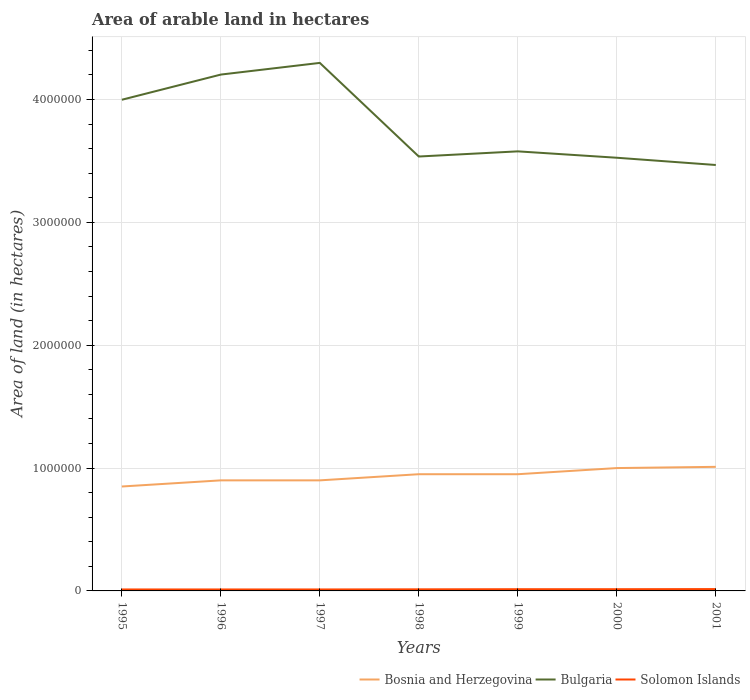Does the line corresponding to Bulgaria intersect with the line corresponding to Solomon Islands?
Your response must be concise. No. Across all years, what is the maximum total arable land in Bosnia and Herzegovina?
Make the answer very short. 8.50e+05. What is the total total arable land in Bosnia and Herzegovina in the graph?
Provide a short and direct response. -1.10e+05. What is the difference between the highest and the second highest total arable land in Solomon Islands?
Make the answer very short. 3000. What is the difference between the highest and the lowest total arable land in Bosnia and Herzegovina?
Your answer should be compact. 4. What is the difference between two consecutive major ticks on the Y-axis?
Offer a terse response. 1.00e+06. Where does the legend appear in the graph?
Give a very brief answer. Bottom right. How many legend labels are there?
Your answer should be very brief. 3. How are the legend labels stacked?
Provide a succinct answer. Horizontal. What is the title of the graph?
Provide a short and direct response. Area of arable land in hectares. Does "Arab World" appear as one of the legend labels in the graph?
Give a very brief answer. No. What is the label or title of the X-axis?
Make the answer very short. Years. What is the label or title of the Y-axis?
Your answer should be very brief. Area of land (in hectares). What is the Area of land (in hectares) in Bosnia and Herzegovina in 1995?
Your answer should be very brief. 8.50e+05. What is the Area of land (in hectares) in Bulgaria in 1995?
Offer a very short reply. 4.00e+06. What is the Area of land (in hectares) of Solomon Islands in 1995?
Offer a very short reply. 1.20e+04. What is the Area of land (in hectares) of Bosnia and Herzegovina in 1996?
Give a very brief answer. 9.00e+05. What is the Area of land (in hectares) of Bulgaria in 1996?
Make the answer very short. 4.20e+06. What is the Area of land (in hectares) in Solomon Islands in 1996?
Your answer should be compact. 1.20e+04. What is the Area of land (in hectares) of Bulgaria in 1997?
Ensure brevity in your answer.  4.30e+06. What is the Area of land (in hectares) in Solomon Islands in 1997?
Give a very brief answer. 1.20e+04. What is the Area of land (in hectares) of Bosnia and Herzegovina in 1998?
Your response must be concise. 9.50e+05. What is the Area of land (in hectares) of Bulgaria in 1998?
Your response must be concise. 3.54e+06. What is the Area of land (in hectares) of Solomon Islands in 1998?
Provide a short and direct response. 1.30e+04. What is the Area of land (in hectares) in Bosnia and Herzegovina in 1999?
Keep it short and to the point. 9.50e+05. What is the Area of land (in hectares) of Bulgaria in 1999?
Provide a short and direct response. 3.58e+06. What is the Area of land (in hectares) in Solomon Islands in 1999?
Keep it short and to the point. 1.40e+04. What is the Area of land (in hectares) in Bosnia and Herzegovina in 2000?
Provide a succinct answer. 1.00e+06. What is the Area of land (in hectares) of Bulgaria in 2000?
Offer a very short reply. 3.53e+06. What is the Area of land (in hectares) of Solomon Islands in 2000?
Make the answer very short. 1.40e+04. What is the Area of land (in hectares) in Bosnia and Herzegovina in 2001?
Your response must be concise. 1.01e+06. What is the Area of land (in hectares) in Bulgaria in 2001?
Offer a terse response. 3.47e+06. What is the Area of land (in hectares) of Solomon Islands in 2001?
Offer a terse response. 1.50e+04. Across all years, what is the maximum Area of land (in hectares) of Bosnia and Herzegovina?
Ensure brevity in your answer.  1.01e+06. Across all years, what is the maximum Area of land (in hectares) of Bulgaria?
Make the answer very short. 4.30e+06. Across all years, what is the maximum Area of land (in hectares) in Solomon Islands?
Provide a short and direct response. 1.50e+04. Across all years, what is the minimum Area of land (in hectares) in Bosnia and Herzegovina?
Keep it short and to the point. 8.50e+05. Across all years, what is the minimum Area of land (in hectares) of Bulgaria?
Offer a terse response. 3.47e+06. Across all years, what is the minimum Area of land (in hectares) of Solomon Islands?
Your answer should be compact. 1.20e+04. What is the total Area of land (in hectares) in Bosnia and Herzegovina in the graph?
Give a very brief answer. 6.56e+06. What is the total Area of land (in hectares) of Bulgaria in the graph?
Give a very brief answer. 2.66e+07. What is the total Area of land (in hectares) of Solomon Islands in the graph?
Ensure brevity in your answer.  9.20e+04. What is the difference between the Area of land (in hectares) in Bulgaria in 1995 and that in 1996?
Ensure brevity in your answer.  -2.05e+05. What is the difference between the Area of land (in hectares) in Bosnia and Herzegovina in 1995 and that in 1997?
Your response must be concise. -5.00e+04. What is the difference between the Area of land (in hectares) of Bulgaria in 1995 and that in 1997?
Your answer should be compact. -3.00e+05. What is the difference between the Area of land (in hectares) in Solomon Islands in 1995 and that in 1997?
Your response must be concise. 0. What is the difference between the Area of land (in hectares) of Bulgaria in 1995 and that in 1998?
Offer a terse response. 4.62e+05. What is the difference between the Area of land (in hectares) of Solomon Islands in 1995 and that in 1998?
Make the answer very short. -1000. What is the difference between the Area of land (in hectares) in Bulgaria in 1995 and that in 1999?
Offer a terse response. 4.20e+05. What is the difference between the Area of land (in hectares) of Solomon Islands in 1995 and that in 1999?
Make the answer very short. -2000. What is the difference between the Area of land (in hectares) in Bosnia and Herzegovina in 1995 and that in 2000?
Your answer should be compact. -1.50e+05. What is the difference between the Area of land (in hectares) of Bulgaria in 1995 and that in 2000?
Provide a succinct answer. 4.72e+05. What is the difference between the Area of land (in hectares) in Solomon Islands in 1995 and that in 2000?
Keep it short and to the point. -2000. What is the difference between the Area of land (in hectares) of Bosnia and Herzegovina in 1995 and that in 2001?
Your answer should be very brief. -1.60e+05. What is the difference between the Area of land (in hectares) of Bulgaria in 1995 and that in 2001?
Ensure brevity in your answer.  5.31e+05. What is the difference between the Area of land (in hectares) in Solomon Islands in 1995 and that in 2001?
Provide a succinct answer. -3000. What is the difference between the Area of land (in hectares) in Bosnia and Herzegovina in 1996 and that in 1997?
Offer a terse response. 0. What is the difference between the Area of land (in hectares) in Bulgaria in 1996 and that in 1997?
Ensure brevity in your answer.  -9.50e+04. What is the difference between the Area of land (in hectares) in Bosnia and Herzegovina in 1996 and that in 1998?
Ensure brevity in your answer.  -5.00e+04. What is the difference between the Area of land (in hectares) of Bulgaria in 1996 and that in 1998?
Keep it short and to the point. 6.67e+05. What is the difference between the Area of land (in hectares) of Solomon Islands in 1996 and that in 1998?
Keep it short and to the point. -1000. What is the difference between the Area of land (in hectares) of Bosnia and Herzegovina in 1996 and that in 1999?
Ensure brevity in your answer.  -5.00e+04. What is the difference between the Area of land (in hectares) in Bulgaria in 1996 and that in 1999?
Provide a short and direct response. 6.25e+05. What is the difference between the Area of land (in hectares) of Solomon Islands in 1996 and that in 1999?
Make the answer very short. -2000. What is the difference between the Area of land (in hectares) of Bosnia and Herzegovina in 1996 and that in 2000?
Keep it short and to the point. -1.00e+05. What is the difference between the Area of land (in hectares) of Bulgaria in 1996 and that in 2000?
Your response must be concise. 6.77e+05. What is the difference between the Area of land (in hectares) of Solomon Islands in 1996 and that in 2000?
Offer a terse response. -2000. What is the difference between the Area of land (in hectares) of Bosnia and Herzegovina in 1996 and that in 2001?
Provide a short and direct response. -1.10e+05. What is the difference between the Area of land (in hectares) of Bulgaria in 1996 and that in 2001?
Keep it short and to the point. 7.36e+05. What is the difference between the Area of land (in hectares) in Solomon Islands in 1996 and that in 2001?
Provide a short and direct response. -3000. What is the difference between the Area of land (in hectares) in Bosnia and Herzegovina in 1997 and that in 1998?
Give a very brief answer. -5.00e+04. What is the difference between the Area of land (in hectares) in Bulgaria in 1997 and that in 1998?
Offer a terse response. 7.62e+05. What is the difference between the Area of land (in hectares) in Solomon Islands in 1997 and that in 1998?
Your response must be concise. -1000. What is the difference between the Area of land (in hectares) in Bulgaria in 1997 and that in 1999?
Ensure brevity in your answer.  7.20e+05. What is the difference between the Area of land (in hectares) in Solomon Islands in 1997 and that in 1999?
Give a very brief answer. -2000. What is the difference between the Area of land (in hectares) in Bulgaria in 1997 and that in 2000?
Provide a short and direct response. 7.72e+05. What is the difference between the Area of land (in hectares) in Solomon Islands in 1997 and that in 2000?
Your answer should be compact. -2000. What is the difference between the Area of land (in hectares) of Bosnia and Herzegovina in 1997 and that in 2001?
Your answer should be very brief. -1.10e+05. What is the difference between the Area of land (in hectares) in Bulgaria in 1997 and that in 2001?
Make the answer very short. 8.31e+05. What is the difference between the Area of land (in hectares) of Solomon Islands in 1997 and that in 2001?
Ensure brevity in your answer.  -3000. What is the difference between the Area of land (in hectares) of Bulgaria in 1998 and that in 1999?
Make the answer very short. -4.20e+04. What is the difference between the Area of land (in hectares) in Solomon Islands in 1998 and that in 1999?
Make the answer very short. -1000. What is the difference between the Area of land (in hectares) of Bosnia and Herzegovina in 1998 and that in 2000?
Ensure brevity in your answer.  -5.00e+04. What is the difference between the Area of land (in hectares) of Bulgaria in 1998 and that in 2000?
Your answer should be very brief. 10000. What is the difference between the Area of land (in hectares) of Solomon Islands in 1998 and that in 2000?
Keep it short and to the point. -1000. What is the difference between the Area of land (in hectares) of Bosnia and Herzegovina in 1998 and that in 2001?
Your answer should be very brief. -6.00e+04. What is the difference between the Area of land (in hectares) in Bulgaria in 1998 and that in 2001?
Provide a succinct answer. 6.90e+04. What is the difference between the Area of land (in hectares) in Solomon Islands in 1998 and that in 2001?
Make the answer very short. -2000. What is the difference between the Area of land (in hectares) of Bosnia and Herzegovina in 1999 and that in 2000?
Your answer should be compact. -5.00e+04. What is the difference between the Area of land (in hectares) of Bulgaria in 1999 and that in 2000?
Provide a short and direct response. 5.20e+04. What is the difference between the Area of land (in hectares) of Bosnia and Herzegovina in 1999 and that in 2001?
Keep it short and to the point. -6.00e+04. What is the difference between the Area of land (in hectares) in Bulgaria in 1999 and that in 2001?
Your answer should be compact. 1.11e+05. What is the difference between the Area of land (in hectares) in Solomon Islands in 1999 and that in 2001?
Your answer should be compact. -1000. What is the difference between the Area of land (in hectares) in Bulgaria in 2000 and that in 2001?
Offer a very short reply. 5.90e+04. What is the difference between the Area of land (in hectares) of Solomon Islands in 2000 and that in 2001?
Make the answer very short. -1000. What is the difference between the Area of land (in hectares) of Bosnia and Herzegovina in 1995 and the Area of land (in hectares) of Bulgaria in 1996?
Give a very brief answer. -3.35e+06. What is the difference between the Area of land (in hectares) in Bosnia and Herzegovina in 1995 and the Area of land (in hectares) in Solomon Islands in 1996?
Give a very brief answer. 8.38e+05. What is the difference between the Area of land (in hectares) of Bulgaria in 1995 and the Area of land (in hectares) of Solomon Islands in 1996?
Offer a terse response. 3.99e+06. What is the difference between the Area of land (in hectares) in Bosnia and Herzegovina in 1995 and the Area of land (in hectares) in Bulgaria in 1997?
Give a very brief answer. -3.45e+06. What is the difference between the Area of land (in hectares) of Bosnia and Herzegovina in 1995 and the Area of land (in hectares) of Solomon Islands in 1997?
Offer a terse response. 8.38e+05. What is the difference between the Area of land (in hectares) in Bulgaria in 1995 and the Area of land (in hectares) in Solomon Islands in 1997?
Offer a very short reply. 3.99e+06. What is the difference between the Area of land (in hectares) in Bosnia and Herzegovina in 1995 and the Area of land (in hectares) in Bulgaria in 1998?
Make the answer very short. -2.69e+06. What is the difference between the Area of land (in hectares) in Bosnia and Herzegovina in 1995 and the Area of land (in hectares) in Solomon Islands in 1998?
Your answer should be very brief. 8.37e+05. What is the difference between the Area of land (in hectares) of Bulgaria in 1995 and the Area of land (in hectares) of Solomon Islands in 1998?
Your answer should be very brief. 3.98e+06. What is the difference between the Area of land (in hectares) in Bosnia and Herzegovina in 1995 and the Area of land (in hectares) in Bulgaria in 1999?
Your answer should be very brief. -2.73e+06. What is the difference between the Area of land (in hectares) in Bosnia and Herzegovina in 1995 and the Area of land (in hectares) in Solomon Islands in 1999?
Offer a terse response. 8.36e+05. What is the difference between the Area of land (in hectares) of Bulgaria in 1995 and the Area of land (in hectares) of Solomon Islands in 1999?
Offer a very short reply. 3.98e+06. What is the difference between the Area of land (in hectares) of Bosnia and Herzegovina in 1995 and the Area of land (in hectares) of Bulgaria in 2000?
Make the answer very short. -2.68e+06. What is the difference between the Area of land (in hectares) of Bosnia and Herzegovina in 1995 and the Area of land (in hectares) of Solomon Islands in 2000?
Ensure brevity in your answer.  8.36e+05. What is the difference between the Area of land (in hectares) in Bulgaria in 1995 and the Area of land (in hectares) in Solomon Islands in 2000?
Keep it short and to the point. 3.98e+06. What is the difference between the Area of land (in hectares) in Bosnia and Herzegovina in 1995 and the Area of land (in hectares) in Bulgaria in 2001?
Keep it short and to the point. -2.62e+06. What is the difference between the Area of land (in hectares) in Bosnia and Herzegovina in 1995 and the Area of land (in hectares) in Solomon Islands in 2001?
Make the answer very short. 8.35e+05. What is the difference between the Area of land (in hectares) in Bulgaria in 1995 and the Area of land (in hectares) in Solomon Islands in 2001?
Make the answer very short. 3.98e+06. What is the difference between the Area of land (in hectares) of Bosnia and Herzegovina in 1996 and the Area of land (in hectares) of Bulgaria in 1997?
Ensure brevity in your answer.  -3.40e+06. What is the difference between the Area of land (in hectares) of Bosnia and Herzegovina in 1996 and the Area of land (in hectares) of Solomon Islands in 1997?
Offer a very short reply. 8.88e+05. What is the difference between the Area of land (in hectares) of Bulgaria in 1996 and the Area of land (in hectares) of Solomon Islands in 1997?
Provide a short and direct response. 4.19e+06. What is the difference between the Area of land (in hectares) of Bosnia and Herzegovina in 1996 and the Area of land (in hectares) of Bulgaria in 1998?
Make the answer very short. -2.64e+06. What is the difference between the Area of land (in hectares) in Bosnia and Herzegovina in 1996 and the Area of land (in hectares) in Solomon Islands in 1998?
Provide a short and direct response. 8.87e+05. What is the difference between the Area of land (in hectares) of Bulgaria in 1996 and the Area of land (in hectares) of Solomon Islands in 1998?
Provide a short and direct response. 4.19e+06. What is the difference between the Area of land (in hectares) of Bosnia and Herzegovina in 1996 and the Area of land (in hectares) of Bulgaria in 1999?
Provide a short and direct response. -2.68e+06. What is the difference between the Area of land (in hectares) of Bosnia and Herzegovina in 1996 and the Area of land (in hectares) of Solomon Islands in 1999?
Provide a succinct answer. 8.86e+05. What is the difference between the Area of land (in hectares) of Bulgaria in 1996 and the Area of land (in hectares) of Solomon Islands in 1999?
Give a very brief answer. 4.19e+06. What is the difference between the Area of land (in hectares) of Bosnia and Herzegovina in 1996 and the Area of land (in hectares) of Bulgaria in 2000?
Provide a short and direct response. -2.63e+06. What is the difference between the Area of land (in hectares) in Bosnia and Herzegovina in 1996 and the Area of land (in hectares) in Solomon Islands in 2000?
Make the answer very short. 8.86e+05. What is the difference between the Area of land (in hectares) of Bulgaria in 1996 and the Area of land (in hectares) of Solomon Islands in 2000?
Provide a succinct answer. 4.19e+06. What is the difference between the Area of land (in hectares) in Bosnia and Herzegovina in 1996 and the Area of land (in hectares) in Bulgaria in 2001?
Give a very brief answer. -2.57e+06. What is the difference between the Area of land (in hectares) of Bosnia and Herzegovina in 1996 and the Area of land (in hectares) of Solomon Islands in 2001?
Your answer should be compact. 8.85e+05. What is the difference between the Area of land (in hectares) in Bulgaria in 1996 and the Area of land (in hectares) in Solomon Islands in 2001?
Your answer should be very brief. 4.19e+06. What is the difference between the Area of land (in hectares) in Bosnia and Herzegovina in 1997 and the Area of land (in hectares) in Bulgaria in 1998?
Offer a terse response. -2.64e+06. What is the difference between the Area of land (in hectares) of Bosnia and Herzegovina in 1997 and the Area of land (in hectares) of Solomon Islands in 1998?
Keep it short and to the point. 8.87e+05. What is the difference between the Area of land (in hectares) of Bulgaria in 1997 and the Area of land (in hectares) of Solomon Islands in 1998?
Provide a short and direct response. 4.28e+06. What is the difference between the Area of land (in hectares) of Bosnia and Herzegovina in 1997 and the Area of land (in hectares) of Bulgaria in 1999?
Your answer should be compact. -2.68e+06. What is the difference between the Area of land (in hectares) in Bosnia and Herzegovina in 1997 and the Area of land (in hectares) in Solomon Islands in 1999?
Make the answer very short. 8.86e+05. What is the difference between the Area of land (in hectares) in Bulgaria in 1997 and the Area of land (in hectares) in Solomon Islands in 1999?
Keep it short and to the point. 4.28e+06. What is the difference between the Area of land (in hectares) in Bosnia and Herzegovina in 1997 and the Area of land (in hectares) in Bulgaria in 2000?
Your answer should be compact. -2.63e+06. What is the difference between the Area of land (in hectares) in Bosnia and Herzegovina in 1997 and the Area of land (in hectares) in Solomon Islands in 2000?
Ensure brevity in your answer.  8.86e+05. What is the difference between the Area of land (in hectares) of Bulgaria in 1997 and the Area of land (in hectares) of Solomon Islands in 2000?
Your answer should be very brief. 4.28e+06. What is the difference between the Area of land (in hectares) in Bosnia and Herzegovina in 1997 and the Area of land (in hectares) in Bulgaria in 2001?
Keep it short and to the point. -2.57e+06. What is the difference between the Area of land (in hectares) of Bosnia and Herzegovina in 1997 and the Area of land (in hectares) of Solomon Islands in 2001?
Give a very brief answer. 8.85e+05. What is the difference between the Area of land (in hectares) in Bulgaria in 1997 and the Area of land (in hectares) in Solomon Islands in 2001?
Make the answer very short. 4.28e+06. What is the difference between the Area of land (in hectares) of Bosnia and Herzegovina in 1998 and the Area of land (in hectares) of Bulgaria in 1999?
Keep it short and to the point. -2.63e+06. What is the difference between the Area of land (in hectares) of Bosnia and Herzegovina in 1998 and the Area of land (in hectares) of Solomon Islands in 1999?
Offer a terse response. 9.36e+05. What is the difference between the Area of land (in hectares) of Bulgaria in 1998 and the Area of land (in hectares) of Solomon Islands in 1999?
Ensure brevity in your answer.  3.52e+06. What is the difference between the Area of land (in hectares) of Bosnia and Herzegovina in 1998 and the Area of land (in hectares) of Bulgaria in 2000?
Give a very brief answer. -2.58e+06. What is the difference between the Area of land (in hectares) in Bosnia and Herzegovina in 1998 and the Area of land (in hectares) in Solomon Islands in 2000?
Provide a succinct answer. 9.36e+05. What is the difference between the Area of land (in hectares) in Bulgaria in 1998 and the Area of land (in hectares) in Solomon Islands in 2000?
Ensure brevity in your answer.  3.52e+06. What is the difference between the Area of land (in hectares) in Bosnia and Herzegovina in 1998 and the Area of land (in hectares) in Bulgaria in 2001?
Make the answer very short. -2.52e+06. What is the difference between the Area of land (in hectares) in Bosnia and Herzegovina in 1998 and the Area of land (in hectares) in Solomon Islands in 2001?
Provide a short and direct response. 9.35e+05. What is the difference between the Area of land (in hectares) of Bulgaria in 1998 and the Area of land (in hectares) of Solomon Islands in 2001?
Provide a succinct answer. 3.52e+06. What is the difference between the Area of land (in hectares) of Bosnia and Herzegovina in 1999 and the Area of land (in hectares) of Bulgaria in 2000?
Provide a succinct answer. -2.58e+06. What is the difference between the Area of land (in hectares) of Bosnia and Herzegovina in 1999 and the Area of land (in hectares) of Solomon Islands in 2000?
Your answer should be very brief. 9.36e+05. What is the difference between the Area of land (in hectares) in Bulgaria in 1999 and the Area of land (in hectares) in Solomon Islands in 2000?
Offer a terse response. 3.56e+06. What is the difference between the Area of land (in hectares) of Bosnia and Herzegovina in 1999 and the Area of land (in hectares) of Bulgaria in 2001?
Make the answer very short. -2.52e+06. What is the difference between the Area of land (in hectares) of Bosnia and Herzegovina in 1999 and the Area of land (in hectares) of Solomon Islands in 2001?
Give a very brief answer. 9.35e+05. What is the difference between the Area of land (in hectares) in Bulgaria in 1999 and the Area of land (in hectares) in Solomon Islands in 2001?
Keep it short and to the point. 3.56e+06. What is the difference between the Area of land (in hectares) in Bosnia and Herzegovina in 2000 and the Area of land (in hectares) in Bulgaria in 2001?
Make the answer very short. -2.47e+06. What is the difference between the Area of land (in hectares) in Bosnia and Herzegovina in 2000 and the Area of land (in hectares) in Solomon Islands in 2001?
Offer a very short reply. 9.85e+05. What is the difference between the Area of land (in hectares) in Bulgaria in 2000 and the Area of land (in hectares) in Solomon Islands in 2001?
Offer a terse response. 3.51e+06. What is the average Area of land (in hectares) of Bosnia and Herzegovina per year?
Offer a terse response. 9.37e+05. What is the average Area of land (in hectares) in Bulgaria per year?
Your answer should be compact. 3.80e+06. What is the average Area of land (in hectares) in Solomon Islands per year?
Offer a very short reply. 1.31e+04. In the year 1995, what is the difference between the Area of land (in hectares) in Bosnia and Herzegovina and Area of land (in hectares) in Bulgaria?
Your answer should be compact. -3.15e+06. In the year 1995, what is the difference between the Area of land (in hectares) of Bosnia and Herzegovina and Area of land (in hectares) of Solomon Islands?
Offer a terse response. 8.38e+05. In the year 1995, what is the difference between the Area of land (in hectares) of Bulgaria and Area of land (in hectares) of Solomon Islands?
Offer a very short reply. 3.99e+06. In the year 1996, what is the difference between the Area of land (in hectares) in Bosnia and Herzegovina and Area of land (in hectares) in Bulgaria?
Give a very brief answer. -3.30e+06. In the year 1996, what is the difference between the Area of land (in hectares) of Bosnia and Herzegovina and Area of land (in hectares) of Solomon Islands?
Give a very brief answer. 8.88e+05. In the year 1996, what is the difference between the Area of land (in hectares) in Bulgaria and Area of land (in hectares) in Solomon Islands?
Offer a terse response. 4.19e+06. In the year 1997, what is the difference between the Area of land (in hectares) in Bosnia and Herzegovina and Area of land (in hectares) in Bulgaria?
Offer a very short reply. -3.40e+06. In the year 1997, what is the difference between the Area of land (in hectares) of Bosnia and Herzegovina and Area of land (in hectares) of Solomon Islands?
Your answer should be compact. 8.88e+05. In the year 1997, what is the difference between the Area of land (in hectares) of Bulgaria and Area of land (in hectares) of Solomon Islands?
Provide a short and direct response. 4.29e+06. In the year 1998, what is the difference between the Area of land (in hectares) of Bosnia and Herzegovina and Area of land (in hectares) of Bulgaria?
Your response must be concise. -2.59e+06. In the year 1998, what is the difference between the Area of land (in hectares) of Bosnia and Herzegovina and Area of land (in hectares) of Solomon Islands?
Offer a very short reply. 9.37e+05. In the year 1998, what is the difference between the Area of land (in hectares) of Bulgaria and Area of land (in hectares) of Solomon Islands?
Provide a short and direct response. 3.52e+06. In the year 1999, what is the difference between the Area of land (in hectares) of Bosnia and Herzegovina and Area of land (in hectares) of Bulgaria?
Your answer should be very brief. -2.63e+06. In the year 1999, what is the difference between the Area of land (in hectares) of Bosnia and Herzegovina and Area of land (in hectares) of Solomon Islands?
Your answer should be compact. 9.36e+05. In the year 1999, what is the difference between the Area of land (in hectares) in Bulgaria and Area of land (in hectares) in Solomon Islands?
Your response must be concise. 3.56e+06. In the year 2000, what is the difference between the Area of land (in hectares) in Bosnia and Herzegovina and Area of land (in hectares) in Bulgaria?
Make the answer very short. -2.53e+06. In the year 2000, what is the difference between the Area of land (in hectares) in Bosnia and Herzegovina and Area of land (in hectares) in Solomon Islands?
Keep it short and to the point. 9.86e+05. In the year 2000, what is the difference between the Area of land (in hectares) of Bulgaria and Area of land (in hectares) of Solomon Islands?
Your answer should be very brief. 3.51e+06. In the year 2001, what is the difference between the Area of land (in hectares) of Bosnia and Herzegovina and Area of land (in hectares) of Bulgaria?
Offer a terse response. -2.46e+06. In the year 2001, what is the difference between the Area of land (in hectares) of Bosnia and Herzegovina and Area of land (in hectares) of Solomon Islands?
Ensure brevity in your answer.  9.95e+05. In the year 2001, what is the difference between the Area of land (in hectares) of Bulgaria and Area of land (in hectares) of Solomon Islands?
Provide a succinct answer. 3.45e+06. What is the ratio of the Area of land (in hectares) in Bosnia and Herzegovina in 1995 to that in 1996?
Ensure brevity in your answer.  0.94. What is the ratio of the Area of land (in hectares) in Bulgaria in 1995 to that in 1996?
Keep it short and to the point. 0.95. What is the ratio of the Area of land (in hectares) of Bosnia and Herzegovina in 1995 to that in 1997?
Provide a succinct answer. 0.94. What is the ratio of the Area of land (in hectares) of Bulgaria in 1995 to that in 1997?
Keep it short and to the point. 0.93. What is the ratio of the Area of land (in hectares) in Bosnia and Herzegovina in 1995 to that in 1998?
Give a very brief answer. 0.89. What is the ratio of the Area of land (in hectares) in Bulgaria in 1995 to that in 1998?
Offer a very short reply. 1.13. What is the ratio of the Area of land (in hectares) in Bosnia and Herzegovina in 1995 to that in 1999?
Provide a short and direct response. 0.89. What is the ratio of the Area of land (in hectares) in Bulgaria in 1995 to that in 1999?
Offer a very short reply. 1.12. What is the ratio of the Area of land (in hectares) of Solomon Islands in 1995 to that in 1999?
Your answer should be very brief. 0.86. What is the ratio of the Area of land (in hectares) in Bulgaria in 1995 to that in 2000?
Your answer should be very brief. 1.13. What is the ratio of the Area of land (in hectares) in Solomon Islands in 1995 to that in 2000?
Give a very brief answer. 0.86. What is the ratio of the Area of land (in hectares) in Bosnia and Herzegovina in 1995 to that in 2001?
Ensure brevity in your answer.  0.84. What is the ratio of the Area of land (in hectares) of Bulgaria in 1995 to that in 2001?
Your answer should be very brief. 1.15. What is the ratio of the Area of land (in hectares) in Solomon Islands in 1995 to that in 2001?
Give a very brief answer. 0.8. What is the ratio of the Area of land (in hectares) in Bulgaria in 1996 to that in 1997?
Your answer should be compact. 0.98. What is the ratio of the Area of land (in hectares) of Bulgaria in 1996 to that in 1998?
Provide a short and direct response. 1.19. What is the ratio of the Area of land (in hectares) of Solomon Islands in 1996 to that in 1998?
Give a very brief answer. 0.92. What is the ratio of the Area of land (in hectares) in Bulgaria in 1996 to that in 1999?
Make the answer very short. 1.17. What is the ratio of the Area of land (in hectares) of Solomon Islands in 1996 to that in 1999?
Offer a terse response. 0.86. What is the ratio of the Area of land (in hectares) of Bosnia and Herzegovina in 1996 to that in 2000?
Provide a succinct answer. 0.9. What is the ratio of the Area of land (in hectares) of Bulgaria in 1996 to that in 2000?
Provide a short and direct response. 1.19. What is the ratio of the Area of land (in hectares) of Solomon Islands in 1996 to that in 2000?
Provide a short and direct response. 0.86. What is the ratio of the Area of land (in hectares) of Bosnia and Herzegovina in 1996 to that in 2001?
Your answer should be very brief. 0.89. What is the ratio of the Area of land (in hectares) of Bulgaria in 1996 to that in 2001?
Your answer should be very brief. 1.21. What is the ratio of the Area of land (in hectares) of Solomon Islands in 1996 to that in 2001?
Your response must be concise. 0.8. What is the ratio of the Area of land (in hectares) in Bosnia and Herzegovina in 1997 to that in 1998?
Offer a terse response. 0.95. What is the ratio of the Area of land (in hectares) in Bulgaria in 1997 to that in 1998?
Your response must be concise. 1.22. What is the ratio of the Area of land (in hectares) in Bosnia and Herzegovina in 1997 to that in 1999?
Your response must be concise. 0.95. What is the ratio of the Area of land (in hectares) of Bulgaria in 1997 to that in 1999?
Your answer should be compact. 1.2. What is the ratio of the Area of land (in hectares) in Solomon Islands in 1997 to that in 1999?
Your answer should be compact. 0.86. What is the ratio of the Area of land (in hectares) of Bulgaria in 1997 to that in 2000?
Give a very brief answer. 1.22. What is the ratio of the Area of land (in hectares) of Bosnia and Herzegovina in 1997 to that in 2001?
Your response must be concise. 0.89. What is the ratio of the Area of land (in hectares) of Bulgaria in 1997 to that in 2001?
Keep it short and to the point. 1.24. What is the ratio of the Area of land (in hectares) of Solomon Islands in 1997 to that in 2001?
Keep it short and to the point. 0.8. What is the ratio of the Area of land (in hectares) in Bulgaria in 1998 to that in 1999?
Your answer should be very brief. 0.99. What is the ratio of the Area of land (in hectares) in Solomon Islands in 1998 to that in 1999?
Your response must be concise. 0.93. What is the ratio of the Area of land (in hectares) of Bulgaria in 1998 to that in 2000?
Your answer should be compact. 1. What is the ratio of the Area of land (in hectares) of Bosnia and Herzegovina in 1998 to that in 2001?
Provide a succinct answer. 0.94. What is the ratio of the Area of land (in hectares) of Bulgaria in 1998 to that in 2001?
Provide a short and direct response. 1.02. What is the ratio of the Area of land (in hectares) in Solomon Islands in 1998 to that in 2001?
Offer a terse response. 0.87. What is the ratio of the Area of land (in hectares) in Bulgaria in 1999 to that in 2000?
Make the answer very short. 1.01. What is the ratio of the Area of land (in hectares) of Bosnia and Herzegovina in 1999 to that in 2001?
Offer a terse response. 0.94. What is the ratio of the Area of land (in hectares) in Bulgaria in 1999 to that in 2001?
Provide a short and direct response. 1.03. What is the ratio of the Area of land (in hectares) in Bulgaria in 2000 to that in 2001?
Your answer should be very brief. 1.02. What is the ratio of the Area of land (in hectares) of Solomon Islands in 2000 to that in 2001?
Your answer should be very brief. 0.93. What is the difference between the highest and the second highest Area of land (in hectares) in Bulgaria?
Your response must be concise. 9.50e+04. What is the difference between the highest and the second highest Area of land (in hectares) in Solomon Islands?
Offer a very short reply. 1000. What is the difference between the highest and the lowest Area of land (in hectares) in Bulgaria?
Your answer should be compact. 8.31e+05. What is the difference between the highest and the lowest Area of land (in hectares) in Solomon Islands?
Make the answer very short. 3000. 